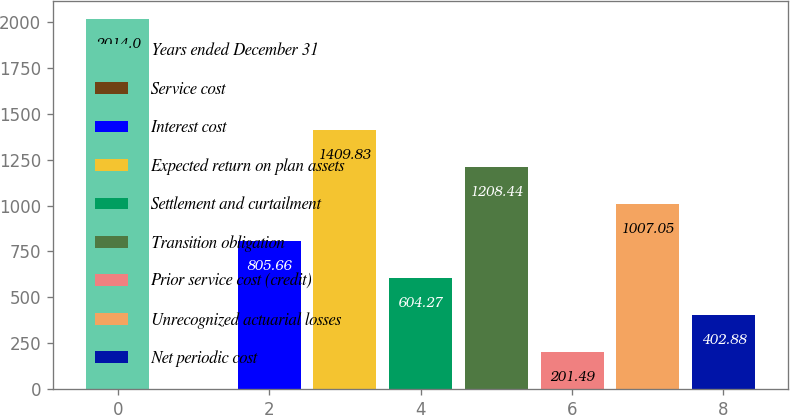Convert chart to OTSL. <chart><loc_0><loc_0><loc_500><loc_500><bar_chart><fcel>Years ended December 31<fcel>Service cost<fcel>Interest cost<fcel>Expected return on plan assets<fcel>Settlement and curtailment<fcel>Transition obligation<fcel>Prior service cost (credit)<fcel>Unrecognized actuarial losses<fcel>Net periodic cost<nl><fcel>2014<fcel>0.1<fcel>805.66<fcel>1409.83<fcel>604.27<fcel>1208.44<fcel>201.49<fcel>1007.05<fcel>402.88<nl></chart> 